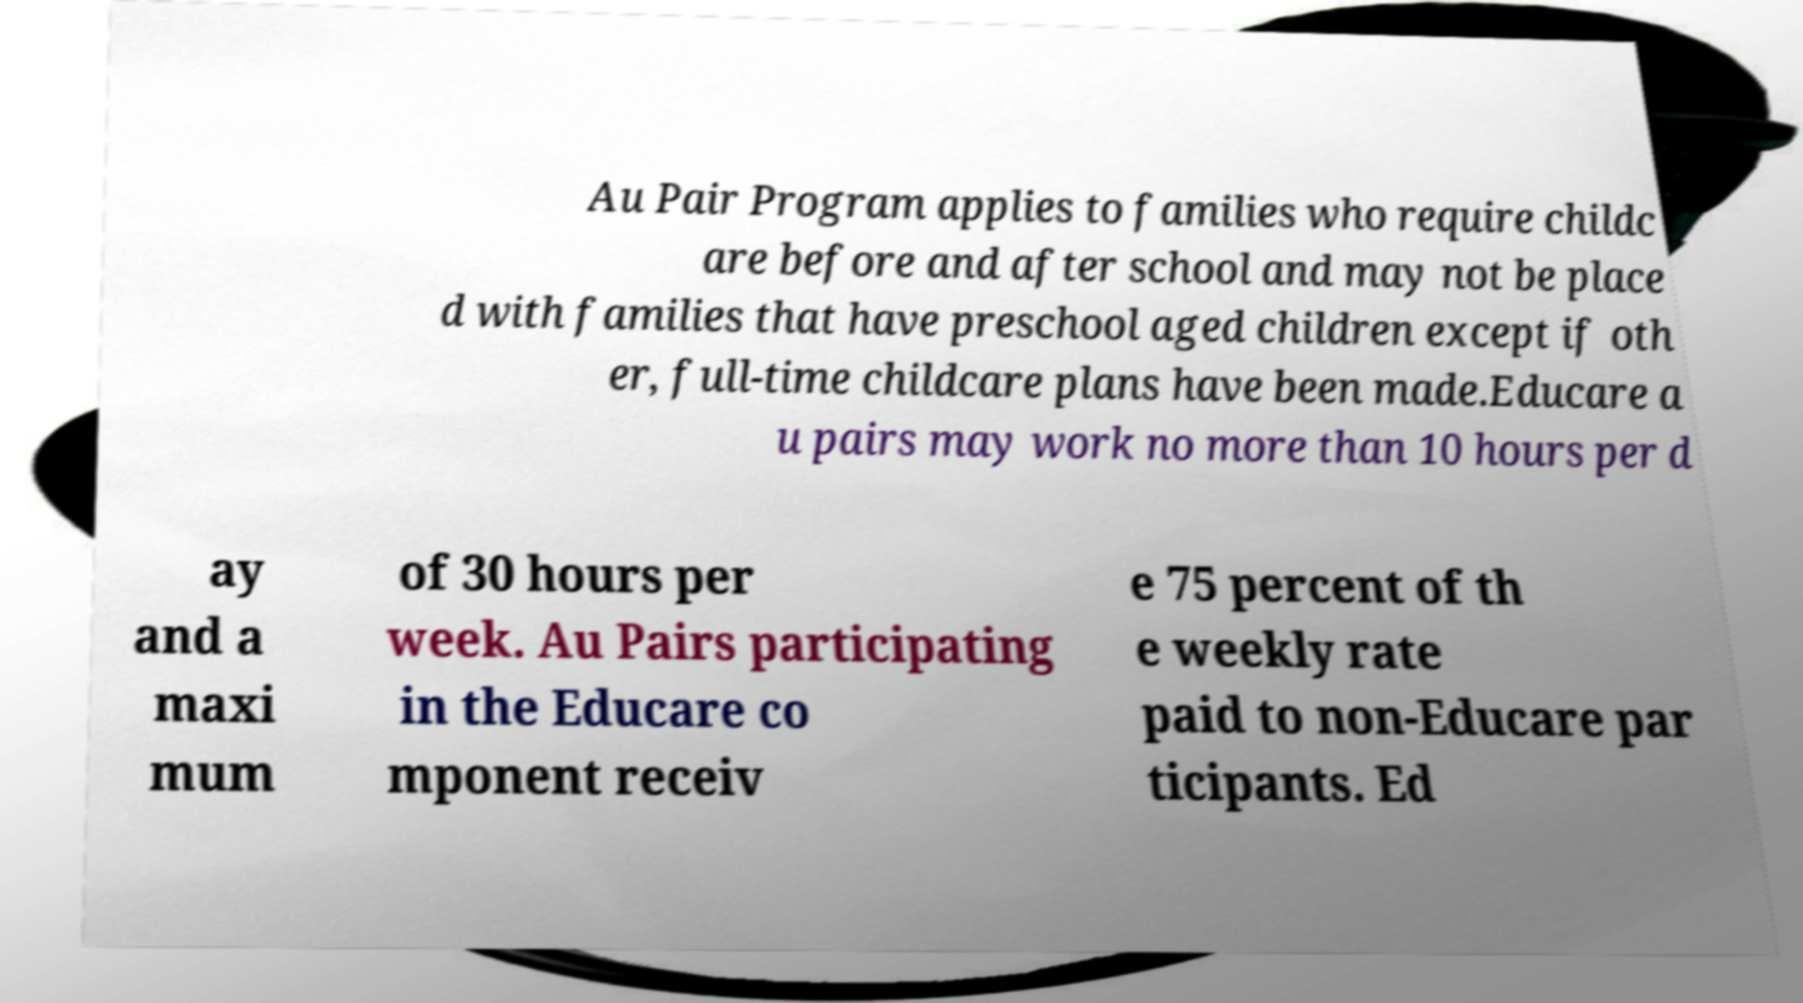There's text embedded in this image that I need extracted. Can you transcribe it verbatim? Au Pair Program applies to families who require childc are before and after school and may not be place d with families that have preschool aged children except if oth er, full-time childcare plans have been made.Educare a u pairs may work no more than 10 hours per d ay and a maxi mum of 30 hours per week. Au Pairs participating in the Educare co mponent receiv e 75 percent of th e weekly rate paid to non-Educare par ticipants. Ed 